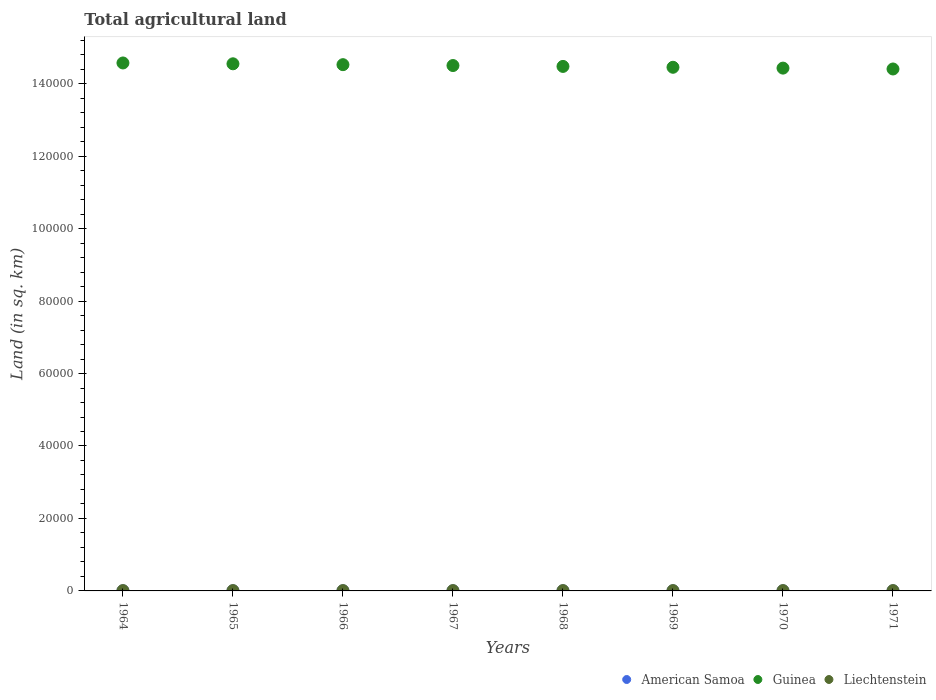How many different coloured dotlines are there?
Your response must be concise. 3. What is the total agricultural land in American Samoa in 1969?
Offer a very short reply. 30. Across all years, what is the maximum total agricultural land in Liechtenstein?
Your answer should be compact. 90. Across all years, what is the minimum total agricultural land in Liechtenstein?
Give a very brief answer. 90. In which year was the total agricultural land in American Samoa maximum?
Offer a terse response. 1964. In which year was the total agricultural land in Guinea minimum?
Your response must be concise. 1971. What is the total total agricultural land in American Samoa in the graph?
Your answer should be compact. 240. What is the difference between the total agricultural land in Guinea in 1967 and that in 1971?
Keep it short and to the point. 950. What is the difference between the total agricultural land in American Samoa in 1966 and the total agricultural land in Liechtenstein in 1971?
Keep it short and to the point. -60. In the year 1971, what is the difference between the total agricultural land in Guinea and total agricultural land in American Samoa?
Make the answer very short. 1.44e+05. In how many years, is the total agricultural land in American Samoa greater than 68000 sq.km?
Your answer should be very brief. 0. Is the difference between the total agricultural land in Guinea in 1969 and 1970 greater than the difference between the total agricultural land in American Samoa in 1969 and 1970?
Ensure brevity in your answer.  Yes. What is the difference between the highest and the lowest total agricultural land in Guinea?
Provide a succinct answer. 1660. Does the total agricultural land in American Samoa monotonically increase over the years?
Make the answer very short. No. How many years are there in the graph?
Ensure brevity in your answer.  8. What is the difference between two consecutive major ticks on the Y-axis?
Make the answer very short. 2.00e+04. Are the values on the major ticks of Y-axis written in scientific E-notation?
Offer a terse response. No. Does the graph contain any zero values?
Ensure brevity in your answer.  No. Does the graph contain grids?
Provide a short and direct response. No. How many legend labels are there?
Keep it short and to the point. 3. What is the title of the graph?
Your response must be concise. Total agricultural land. Does "New Caledonia" appear as one of the legend labels in the graph?
Offer a terse response. No. What is the label or title of the X-axis?
Provide a short and direct response. Years. What is the label or title of the Y-axis?
Make the answer very short. Land (in sq. km). What is the Land (in sq. km) in American Samoa in 1964?
Provide a succinct answer. 30. What is the Land (in sq. km) in Guinea in 1964?
Give a very brief answer. 1.46e+05. What is the Land (in sq. km) of Guinea in 1965?
Your answer should be very brief. 1.45e+05. What is the Land (in sq. km) in Liechtenstein in 1965?
Keep it short and to the point. 90. What is the Land (in sq. km) in Guinea in 1966?
Offer a terse response. 1.45e+05. What is the Land (in sq. km) of American Samoa in 1967?
Offer a very short reply. 30. What is the Land (in sq. km) of Guinea in 1967?
Your answer should be very brief. 1.45e+05. What is the Land (in sq. km) of Liechtenstein in 1967?
Keep it short and to the point. 90. What is the Land (in sq. km) in Guinea in 1968?
Your response must be concise. 1.45e+05. What is the Land (in sq. km) in Liechtenstein in 1968?
Give a very brief answer. 90. What is the Land (in sq. km) of American Samoa in 1969?
Provide a succinct answer. 30. What is the Land (in sq. km) of Guinea in 1969?
Provide a short and direct response. 1.45e+05. What is the Land (in sq. km) of Liechtenstein in 1969?
Your answer should be very brief. 90. What is the Land (in sq. km) of American Samoa in 1970?
Offer a terse response. 30. What is the Land (in sq. km) in Guinea in 1970?
Give a very brief answer. 1.44e+05. What is the Land (in sq. km) of Liechtenstein in 1970?
Give a very brief answer. 90. What is the Land (in sq. km) in Guinea in 1971?
Make the answer very short. 1.44e+05. Across all years, what is the maximum Land (in sq. km) in American Samoa?
Provide a short and direct response. 30. Across all years, what is the maximum Land (in sq. km) in Guinea?
Ensure brevity in your answer.  1.46e+05. Across all years, what is the maximum Land (in sq. km) in Liechtenstein?
Offer a terse response. 90. Across all years, what is the minimum Land (in sq. km) in American Samoa?
Make the answer very short. 30. Across all years, what is the minimum Land (in sq. km) in Guinea?
Offer a terse response. 1.44e+05. What is the total Land (in sq. km) in American Samoa in the graph?
Provide a succinct answer. 240. What is the total Land (in sq. km) of Guinea in the graph?
Offer a very short reply. 1.16e+06. What is the total Land (in sq. km) in Liechtenstein in the graph?
Ensure brevity in your answer.  720. What is the difference between the Land (in sq. km) in Guinea in 1964 and that in 1965?
Make the answer very short. 230. What is the difference between the Land (in sq. km) in Guinea in 1964 and that in 1966?
Ensure brevity in your answer.  470. What is the difference between the Land (in sq. km) of Liechtenstein in 1964 and that in 1966?
Your answer should be very brief. 0. What is the difference between the Land (in sq. km) of Guinea in 1964 and that in 1967?
Your answer should be compact. 710. What is the difference between the Land (in sq. km) of American Samoa in 1964 and that in 1968?
Offer a very short reply. 0. What is the difference between the Land (in sq. km) in Guinea in 1964 and that in 1968?
Ensure brevity in your answer.  950. What is the difference between the Land (in sq. km) of Guinea in 1964 and that in 1969?
Ensure brevity in your answer.  1190. What is the difference between the Land (in sq. km) of Guinea in 1964 and that in 1970?
Your response must be concise. 1420. What is the difference between the Land (in sq. km) in American Samoa in 1964 and that in 1971?
Keep it short and to the point. 0. What is the difference between the Land (in sq. km) of Guinea in 1964 and that in 1971?
Make the answer very short. 1660. What is the difference between the Land (in sq. km) in Liechtenstein in 1964 and that in 1971?
Make the answer very short. 0. What is the difference between the Land (in sq. km) of American Samoa in 1965 and that in 1966?
Make the answer very short. 0. What is the difference between the Land (in sq. km) of Guinea in 1965 and that in 1966?
Provide a short and direct response. 240. What is the difference between the Land (in sq. km) in American Samoa in 1965 and that in 1967?
Offer a terse response. 0. What is the difference between the Land (in sq. km) in Guinea in 1965 and that in 1967?
Provide a short and direct response. 480. What is the difference between the Land (in sq. km) in Liechtenstein in 1965 and that in 1967?
Keep it short and to the point. 0. What is the difference between the Land (in sq. km) in Guinea in 1965 and that in 1968?
Ensure brevity in your answer.  720. What is the difference between the Land (in sq. km) in Liechtenstein in 1965 and that in 1968?
Your response must be concise. 0. What is the difference between the Land (in sq. km) of Guinea in 1965 and that in 1969?
Ensure brevity in your answer.  960. What is the difference between the Land (in sq. km) in American Samoa in 1965 and that in 1970?
Keep it short and to the point. 0. What is the difference between the Land (in sq. km) in Guinea in 1965 and that in 1970?
Your answer should be very brief. 1190. What is the difference between the Land (in sq. km) in Liechtenstein in 1965 and that in 1970?
Your response must be concise. 0. What is the difference between the Land (in sq. km) in Guinea in 1965 and that in 1971?
Your answer should be compact. 1430. What is the difference between the Land (in sq. km) in Guinea in 1966 and that in 1967?
Make the answer very short. 240. What is the difference between the Land (in sq. km) in Guinea in 1966 and that in 1968?
Give a very brief answer. 480. What is the difference between the Land (in sq. km) of Liechtenstein in 1966 and that in 1968?
Your answer should be compact. 0. What is the difference between the Land (in sq. km) of American Samoa in 1966 and that in 1969?
Keep it short and to the point. 0. What is the difference between the Land (in sq. km) of Guinea in 1966 and that in 1969?
Provide a succinct answer. 720. What is the difference between the Land (in sq. km) in Liechtenstein in 1966 and that in 1969?
Make the answer very short. 0. What is the difference between the Land (in sq. km) of American Samoa in 1966 and that in 1970?
Your response must be concise. 0. What is the difference between the Land (in sq. km) in Guinea in 1966 and that in 1970?
Your response must be concise. 950. What is the difference between the Land (in sq. km) of Liechtenstein in 1966 and that in 1970?
Offer a terse response. 0. What is the difference between the Land (in sq. km) in American Samoa in 1966 and that in 1971?
Ensure brevity in your answer.  0. What is the difference between the Land (in sq. km) of Guinea in 1966 and that in 1971?
Offer a terse response. 1190. What is the difference between the Land (in sq. km) of American Samoa in 1967 and that in 1968?
Offer a very short reply. 0. What is the difference between the Land (in sq. km) of Guinea in 1967 and that in 1968?
Make the answer very short. 240. What is the difference between the Land (in sq. km) in Liechtenstein in 1967 and that in 1968?
Your response must be concise. 0. What is the difference between the Land (in sq. km) of Guinea in 1967 and that in 1969?
Make the answer very short. 480. What is the difference between the Land (in sq. km) in Liechtenstein in 1967 and that in 1969?
Your response must be concise. 0. What is the difference between the Land (in sq. km) in Guinea in 1967 and that in 1970?
Ensure brevity in your answer.  710. What is the difference between the Land (in sq. km) in Guinea in 1967 and that in 1971?
Offer a terse response. 950. What is the difference between the Land (in sq. km) of Liechtenstein in 1967 and that in 1971?
Your answer should be compact. 0. What is the difference between the Land (in sq. km) of Guinea in 1968 and that in 1969?
Offer a terse response. 240. What is the difference between the Land (in sq. km) of Liechtenstein in 1968 and that in 1969?
Give a very brief answer. 0. What is the difference between the Land (in sq. km) in Guinea in 1968 and that in 1970?
Your answer should be very brief. 470. What is the difference between the Land (in sq. km) in Liechtenstein in 1968 and that in 1970?
Your answer should be compact. 0. What is the difference between the Land (in sq. km) of American Samoa in 1968 and that in 1971?
Ensure brevity in your answer.  0. What is the difference between the Land (in sq. km) of Guinea in 1968 and that in 1971?
Ensure brevity in your answer.  710. What is the difference between the Land (in sq. km) of Liechtenstein in 1968 and that in 1971?
Give a very brief answer. 0. What is the difference between the Land (in sq. km) in American Samoa in 1969 and that in 1970?
Keep it short and to the point. 0. What is the difference between the Land (in sq. km) in Guinea in 1969 and that in 1970?
Make the answer very short. 230. What is the difference between the Land (in sq. km) of American Samoa in 1969 and that in 1971?
Ensure brevity in your answer.  0. What is the difference between the Land (in sq. km) of Guinea in 1969 and that in 1971?
Provide a short and direct response. 470. What is the difference between the Land (in sq. km) in Liechtenstein in 1969 and that in 1971?
Provide a short and direct response. 0. What is the difference between the Land (in sq. km) in American Samoa in 1970 and that in 1971?
Make the answer very short. 0. What is the difference between the Land (in sq. km) of Guinea in 1970 and that in 1971?
Provide a short and direct response. 240. What is the difference between the Land (in sq. km) of American Samoa in 1964 and the Land (in sq. km) of Guinea in 1965?
Offer a very short reply. -1.45e+05. What is the difference between the Land (in sq. km) in American Samoa in 1964 and the Land (in sq. km) in Liechtenstein in 1965?
Offer a terse response. -60. What is the difference between the Land (in sq. km) in Guinea in 1964 and the Land (in sq. km) in Liechtenstein in 1965?
Offer a terse response. 1.46e+05. What is the difference between the Land (in sq. km) in American Samoa in 1964 and the Land (in sq. km) in Guinea in 1966?
Your answer should be very brief. -1.45e+05. What is the difference between the Land (in sq. km) in American Samoa in 1964 and the Land (in sq. km) in Liechtenstein in 1966?
Provide a short and direct response. -60. What is the difference between the Land (in sq. km) in Guinea in 1964 and the Land (in sq. km) in Liechtenstein in 1966?
Your response must be concise. 1.46e+05. What is the difference between the Land (in sq. km) of American Samoa in 1964 and the Land (in sq. km) of Guinea in 1967?
Your response must be concise. -1.45e+05. What is the difference between the Land (in sq. km) of American Samoa in 1964 and the Land (in sq. km) of Liechtenstein in 1967?
Your answer should be compact. -60. What is the difference between the Land (in sq. km) of Guinea in 1964 and the Land (in sq. km) of Liechtenstein in 1967?
Ensure brevity in your answer.  1.46e+05. What is the difference between the Land (in sq. km) in American Samoa in 1964 and the Land (in sq. km) in Guinea in 1968?
Your answer should be very brief. -1.45e+05. What is the difference between the Land (in sq. km) in American Samoa in 1964 and the Land (in sq. km) in Liechtenstein in 1968?
Your response must be concise. -60. What is the difference between the Land (in sq. km) of Guinea in 1964 and the Land (in sq. km) of Liechtenstein in 1968?
Your answer should be compact. 1.46e+05. What is the difference between the Land (in sq. km) of American Samoa in 1964 and the Land (in sq. km) of Guinea in 1969?
Ensure brevity in your answer.  -1.44e+05. What is the difference between the Land (in sq. km) in American Samoa in 1964 and the Land (in sq. km) in Liechtenstein in 1969?
Keep it short and to the point. -60. What is the difference between the Land (in sq. km) of Guinea in 1964 and the Land (in sq. km) of Liechtenstein in 1969?
Provide a succinct answer. 1.46e+05. What is the difference between the Land (in sq. km) of American Samoa in 1964 and the Land (in sq. km) of Guinea in 1970?
Give a very brief answer. -1.44e+05. What is the difference between the Land (in sq. km) of American Samoa in 1964 and the Land (in sq. km) of Liechtenstein in 1970?
Provide a succinct answer. -60. What is the difference between the Land (in sq. km) of Guinea in 1964 and the Land (in sq. km) of Liechtenstein in 1970?
Give a very brief answer. 1.46e+05. What is the difference between the Land (in sq. km) of American Samoa in 1964 and the Land (in sq. km) of Guinea in 1971?
Ensure brevity in your answer.  -1.44e+05. What is the difference between the Land (in sq. km) of American Samoa in 1964 and the Land (in sq. km) of Liechtenstein in 1971?
Keep it short and to the point. -60. What is the difference between the Land (in sq. km) in Guinea in 1964 and the Land (in sq. km) in Liechtenstein in 1971?
Make the answer very short. 1.46e+05. What is the difference between the Land (in sq. km) in American Samoa in 1965 and the Land (in sq. km) in Guinea in 1966?
Keep it short and to the point. -1.45e+05. What is the difference between the Land (in sq. km) of American Samoa in 1965 and the Land (in sq. km) of Liechtenstein in 1966?
Your answer should be compact. -60. What is the difference between the Land (in sq. km) in Guinea in 1965 and the Land (in sq. km) in Liechtenstein in 1966?
Your response must be concise. 1.45e+05. What is the difference between the Land (in sq. km) in American Samoa in 1965 and the Land (in sq. km) in Guinea in 1967?
Keep it short and to the point. -1.45e+05. What is the difference between the Land (in sq. km) in American Samoa in 1965 and the Land (in sq. km) in Liechtenstein in 1967?
Make the answer very short. -60. What is the difference between the Land (in sq. km) of Guinea in 1965 and the Land (in sq. km) of Liechtenstein in 1967?
Your response must be concise. 1.45e+05. What is the difference between the Land (in sq. km) of American Samoa in 1965 and the Land (in sq. km) of Guinea in 1968?
Ensure brevity in your answer.  -1.45e+05. What is the difference between the Land (in sq. km) in American Samoa in 1965 and the Land (in sq. km) in Liechtenstein in 1968?
Your answer should be very brief. -60. What is the difference between the Land (in sq. km) of Guinea in 1965 and the Land (in sq. km) of Liechtenstein in 1968?
Keep it short and to the point. 1.45e+05. What is the difference between the Land (in sq. km) of American Samoa in 1965 and the Land (in sq. km) of Guinea in 1969?
Your response must be concise. -1.44e+05. What is the difference between the Land (in sq. km) of American Samoa in 1965 and the Land (in sq. km) of Liechtenstein in 1969?
Your answer should be compact. -60. What is the difference between the Land (in sq. km) in Guinea in 1965 and the Land (in sq. km) in Liechtenstein in 1969?
Provide a short and direct response. 1.45e+05. What is the difference between the Land (in sq. km) of American Samoa in 1965 and the Land (in sq. km) of Guinea in 1970?
Your answer should be very brief. -1.44e+05. What is the difference between the Land (in sq. km) in American Samoa in 1965 and the Land (in sq. km) in Liechtenstein in 1970?
Your response must be concise. -60. What is the difference between the Land (in sq. km) in Guinea in 1965 and the Land (in sq. km) in Liechtenstein in 1970?
Provide a short and direct response. 1.45e+05. What is the difference between the Land (in sq. km) in American Samoa in 1965 and the Land (in sq. km) in Guinea in 1971?
Your answer should be compact. -1.44e+05. What is the difference between the Land (in sq. km) in American Samoa in 1965 and the Land (in sq. km) in Liechtenstein in 1971?
Your response must be concise. -60. What is the difference between the Land (in sq. km) of Guinea in 1965 and the Land (in sq. km) of Liechtenstein in 1971?
Keep it short and to the point. 1.45e+05. What is the difference between the Land (in sq. km) of American Samoa in 1966 and the Land (in sq. km) of Guinea in 1967?
Make the answer very short. -1.45e+05. What is the difference between the Land (in sq. km) of American Samoa in 1966 and the Land (in sq. km) of Liechtenstein in 1967?
Offer a very short reply. -60. What is the difference between the Land (in sq. km) in Guinea in 1966 and the Land (in sq. km) in Liechtenstein in 1967?
Give a very brief answer. 1.45e+05. What is the difference between the Land (in sq. km) in American Samoa in 1966 and the Land (in sq. km) in Guinea in 1968?
Provide a succinct answer. -1.45e+05. What is the difference between the Land (in sq. km) in American Samoa in 1966 and the Land (in sq. km) in Liechtenstein in 1968?
Give a very brief answer. -60. What is the difference between the Land (in sq. km) in Guinea in 1966 and the Land (in sq. km) in Liechtenstein in 1968?
Make the answer very short. 1.45e+05. What is the difference between the Land (in sq. km) of American Samoa in 1966 and the Land (in sq. km) of Guinea in 1969?
Offer a terse response. -1.44e+05. What is the difference between the Land (in sq. km) of American Samoa in 1966 and the Land (in sq. km) of Liechtenstein in 1969?
Offer a very short reply. -60. What is the difference between the Land (in sq. km) in Guinea in 1966 and the Land (in sq. km) in Liechtenstein in 1969?
Give a very brief answer. 1.45e+05. What is the difference between the Land (in sq. km) of American Samoa in 1966 and the Land (in sq. km) of Guinea in 1970?
Make the answer very short. -1.44e+05. What is the difference between the Land (in sq. km) of American Samoa in 1966 and the Land (in sq. km) of Liechtenstein in 1970?
Offer a terse response. -60. What is the difference between the Land (in sq. km) of Guinea in 1966 and the Land (in sq. km) of Liechtenstein in 1970?
Keep it short and to the point. 1.45e+05. What is the difference between the Land (in sq. km) in American Samoa in 1966 and the Land (in sq. km) in Guinea in 1971?
Keep it short and to the point. -1.44e+05. What is the difference between the Land (in sq. km) in American Samoa in 1966 and the Land (in sq. km) in Liechtenstein in 1971?
Ensure brevity in your answer.  -60. What is the difference between the Land (in sq. km) of Guinea in 1966 and the Land (in sq. km) of Liechtenstein in 1971?
Your answer should be compact. 1.45e+05. What is the difference between the Land (in sq. km) of American Samoa in 1967 and the Land (in sq. km) of Guinea in 1968?
Your response must be concise. -1.45e+05. What is the difference between the Land (in sq. km) in American Samoa in 1967 and the Land (in sq. km) in Liechtenstein in 1968?
Your answer should be very brief. -60. What is the difference between the Land (in sq. km) in Guinea in 1967 and the Land (in sq. km) in Liechtenstein in 1968?
Offer a terse response. 1.45e+05. What is the difference between the Land (in sq. km) in American Samoa in 1967 and the Land (in sq. km) in Guinea in 1969?
Your answer should be compact. -1.44e+05. What is the difference between the Land (in sq. km) of American Samoa in 1967 and the Land (in sq. km) of Liechtenstein in 1969?
Make the answer very short. -60. What is the difference between the Land (in sq. km) of Guinea in 1967 and the Land (in sq. km) of Liechtenstein in 1969?
Make the answer very short. 1.45e+05. What is the difference between the Land (in sq. km) in American Samoa in 1967 and the Land (in sq. km) in Guinea in 1970?
Keep it short and to the point. -1.44e+05. What is the difference between the Land (in sq. km) of American Samoa in 1967 and the Land (in sq. km) of Liechtenstein in 1970?
Offer a terse response. -60. What is the difference between the Land (in sq. km) in Guinea in 1967 and the Land (in sq. km) in Liechtenstein in 1970?
Make the answer very short. 1.45e+05. What is the difference between the Land (in sq. km) in American Samoa in 1967 and the Land (in sq. km) in Guinea in 1971?
Make the answer very short. -1.44e+05. What is the difference between the Land (in sq. km) in American Samoa in 1967 and the Land (in sq. km) in Liechtenstein in 1971?
Your response must be concise. -60. What is the difference between the Land (in sq. km) of Guinea in 1967 and the Land (in sq. km) of Liechtenstein in 1971?
Give a very brief answer. 1.45e+05. What is the difference between the Land (in sq. km) of American Samoa in 1968 and the Land (in sq. km) of Guinea in 1969?
Your response must be concise. -1.44e+05. What is the difference between the Land (in sq. km) in American Samoa in 1968 and the Land (in sq. km) in Liechtenstein in 1969?
Ensure brevity in your answer.  -60. What is the difference between the Land (in sq. km) in Guinea in 1968 and the Land (in sq. km) in Liechtenstein in 1969?
Give a very brief answer. 1.45e+05. What is the difference between the Land (in sq. km) in American Samoa in 1968 and the Land (in sq. km) in Guinea in 1970?
Make the answer very short. -1.44e+05. What is the difference between the Land (in sq. km) in American Samoa in 1968 and the Land (in sq. km) in Liechtenstein in 1970?
Offer a very short reply. -60. What is the difference between the Land (in sq. km) of Guinea in 1968 and the Land (in sq. km) of Liechtenstein in 1970?
Provide a short and direct response. 1.45e+05. What is the difference between the Land (in sq. km) in American Samoa in 1968 and the Land (in sq. km) in Guinea in 1971?
Your response must be concise. -1.44e+05. What is the difference between the Land (in sq. km) of American Samoa in 1968 and the Land (in sq. km) of Liechtenstein in 1971?
Provide a short and direct response. -60. What is the difference between the Land (in sq. km) in Guinea in 1968 and the Land (in sq. km) in Liechtenstein in 1971?
Your answer should be compact. 1.45e+05. What is the difference between the Land (in sq. km) of American Samoa in 1969 and the Land (in sq. km) of Guinea in 1970?
Make the answer very short. -1.44e+05. What is the difference between the Land (in sq. km) of American Samoa in 1969 and the Land (in sq. km) of Liechtenstein in 1970?
Ensure brevity in your answer.  -60. What is the difference between the Land (in sq. km) in Guinea in 1969 and the Land (in sq. km) in Liechtenstein in 1970?
Give a very brief answer. 1.44e+05. What is the difference between the Land (in sq. km) in American Samoa in 1969 and the Land (in sq. km) in Guinea in 1971?
Your answer should be very brief. -1.44e+05. What is the difference between the Land (in sq. km) in American Samoa in 1969 and the Land (in sq. km) in Liechtenstein in 1971?
Provide a succinct answer. -60. What is the difference between the Land (in sq. km) in Guinea in 1969 and the Land (in sq. km) in Liechtenstein in 1971?
Your answer should be very brief. 1.44e+05. What is the difference between the Land (in sq. km) in American Samoa in 1970 and the Land (in sq. km) in Guinea in 1971?
Provide a succinct answer. -1.44e+05. What is the difference between the Land (in sq. km) in American Samoa in 1970 and the Land (in sq. km) in Liechtenstein in 1971?
Keep it short and to the point. -60. What is the difference between the Land (in sq. km) in Guinea in 1970 and the Land (in sq. km) in Liechtenstein in 1971?
Offer a very short reply. 1.44e+05. What is the average Land (in sq. km) in Guinea per year?
Give a very brief answer. 1.45e+05. What is the average Land (in sq. km) in Liechtenstein per year?
Ensure brevity in your answer.  90. In the year 1964, what is the difference between the Land (in sq. km) of American Samoa and Land (in sq. km) of Guinea?
Offer a terse response. -1.46e+05. In the year 1964, what is the difference between the Land (in sq. km) in American Samoa and Land (in sq. km) in Liechtenstein?
Provide a succinct answer. -60. In the year 1964, what is the difference between the Land (in sq. km) in Guinea and Land (in sq. km) in Liechtenstein?
Your response must be concise. 1.46e+05. In the year 1965, what is the difference between the Land (in sq. km) of American Samoa and Land (in sq. km) of Guinea?
Your answer should be compact. -1.45e+05. In the year 1965, what is the difference between the Land (in sq. km) in American Samoa and Land (in sq. km) in Liechtenstein?
Your answer should be compact. -60. In the year 1965, what is the difference between the Land (in sq. km) of Guinea and Land (in sq. km) of Liechtenstein?
Your response must be concise. 1.45e+05. In the year 1966, what is the difference between the Land (in sq. km) of American Samoa and Land (in sq. km) of Guinea?
Provide a succinct answer. -1.45e+05. In the year 1966, what is the difference between the Land (in sq. km) of American Samoa and Land (in sq. km) of Liechtenstein?
Offer a terse response. -60. In the year 1966, what is the difference between the Land (in sq. km) of Guinea and Land (in sq. km) of Liechtenstein?
Your answer should be compact. 1.45e+05. In the year 1967, what is the difference between the Land (in sq. km) of American Samoa and Land (in sq. km) of Guinea?
Provide a succinct answer. -1.45e+05. In the year 1967, what is the difference between the Land (in sq. km) of American Samoa and Land (in sq. km) of Liechtenstein?
Make the answer very short. -60. In the year 1967, what is the difference between the Land (in sq. km) in Guinea and Land (in sq. km) in Liechtenstein?
Your answer should be compact. 1.45e+05. In the year 1968, what is the difference between the Land (in sq. km) in American Samoa and Land (in sq. km) in Guinea?
Offer a terse response. -1.45e+05. In the year 1968, what is the difference between the Land (in sq. km) in American Samoa and Land (in sq. km) in Liechtenstein?
Keep it short and to the point. -60. In the year 1968, what is the difference between the Land (in sq. km) of Guinea and Land (in sq. km) of Liechtenstein?
Offer a very short reply. 1.45e+05. In the year 1969, what is the difference between the Land (in sq. km) of American Samoa and Land (in sq. km) of Guinea?
Your response must be concise. -1.44e+05. In the year 1969, what is the difference between the Land (in sq. km) of American Samoa and Land (in sq. km) of Liechtenstein?
Offer a very short reply. -60. In the year 1969, what is the difference between the Land (in sq. km) in Guinea and Land (in sq. km) in Liechtenstein?
Keep it short and to the point. 1.44e+05. In the year 1970, what is the difference between the Land (in sq. km) in American Samoa and Land (in sq. km) in Guinea?
Make the answer very short. -1.44e+05. In the year 1970, what is the difference between the Land (in sq. km) in American Samoa and Land (in sq. km) in Liechtenstein?
Make the answer very short. -60. In the year 1970, what is the difference between the Land (in sq. km) in Guinea and Land (in sq. km) in Liechtenstein?
Offer a very short reply. 1.44e+05. In the year 1971, what is the difference between the Land (in sq. km) of American Samoa and Land (in sq. km) of Guinea?
Ensure brevity in your answer.  -1.44e+05. In the year 1971, what is the difference between the Land (in sq. km) of American Samoa and Land (in sq. km) of Liechtenstein?
Offer a very short reply. -60. In the year 1971, what is the difference between the Land (in sq. km) in Guinea and Land (in sq. km) in Liechtenstein?
Your answer should be compact. 1.44e+05. What is the ratio of the Land (in sq. km) in American Samoa in 1964 to that in 1965?
Your response must be concise. 1. What is the ratio of the Land (in sq. km) of Guinea in 1964 to that in 1965?
Ensure brevity in your answer.  1. What is the ratio of the Land (in sq. km) in Liechtenstein in 1964 to that in 1965?
Offer a terse response. 1. What is the ratio of the Land (in sq. km) in American Samoa in 1964 to that in 1966?
Ensure brevity in your answer.  1. What is the ratio of the Land (in sq. km) of Liechtenstein in 1964 to that in 1966?
Offer a very short reply. 1. What is the ratio of the Land (in sq. km) of American Samoa in 1964 to that in 1967?
Give a very brief answer. 1. What is the ratio of the Land (in sq. km) of Guinea in 1964 to that in 1967?
Your answer should be compact. 1. What is the ratio of the Land (in sq. km) of Liechtenstein in 1964 to that in 1967?
Offer a very short reply. 1. What is the ratio of the Land (in sq. km) of Guinea in 1964 to that in 1968?
Keep it short and to the point. 1.01. What is the ratio of the Land (in sq. km) of Guinea in 1964 to that in 1969?
Provide a short and direct response. 1.01. What is the ratio of the Land (in sq. km) of Liechtenstein in 1964 to that in 1969?
Give a very brief answer. 1. What is the ratio of the Land (in sq. km) in American Samoa in 1964 to that in 1970?
Your answer should be very brief. 1. What is the ratio of the Land (in sq. km) in Guinea in 1964 to that in 1970?
Provide a short and direct response. 1.01. What is the ratio of the Land (in sq. km) in American Samoa in 1964 to that in 1971?
Your answer should be compact. 1. What is the ratio of the Land (in sq. km) of Guinea in 1964 to that in 1971?
Your response must be concise. 1.01. What is the ratio of the Land (in sq. km) of Liechtenstein in 1964 to that in 1971?
Offer a terse response. 1. What is the ratio of the Land (in sq. km) in American Samoa in 1965 to that in 1966?
Provide a short and direct response. 1. What is the ratio of the Land (in sq. km) of American Samoa in 1965 to that in 1967?
Ensure brevity in your answer.  1. What is the ratio of the Land (in sq. km) of American Samoa in 1965 to that in 1968?
Your answer should be compact. 1. What is the ratio of the Land (in sq. km) of American Samoa in 1965 to that in 1969?
Offer a very short reply. 1. What is the ratio of the Land (in sq. km) in Guinea in 1965 to that in 1969?
Your answer should be very brief. 1.01. What is the ratio of the Land (in sq. km) in Liechtenstein in 1965 to that in 1969?
Keep it short and to the point. 1. What is the ratio of the Land (in sq. km) in American Samoa in 1965 to that in 1970?
Ensure brevity in your answer.  1. What is the ratio of the Land (in sq. km) in Guinea in 1965 to that in 1970?
Give a very brief answer. 1.01. What is the ratio of the Land (in sq. km) of Guinea in 1965 to that in 1971?
Your answer should be very brief. 1.01. What is the ratio of the Land (in sq. km) of Liechtenstein in 1965 to that in 1971?
Your answer should be compact. 1. What is the ratio of the Land (in sq. km) in American Samoa in 1966 to that in 1967?
Give a very brief answer. 1. What is the ratio of the Land (in sq. km) of Guinea in 1966 to that in 1967?
Your answer should be very brief. 1. What is the ratio of the Land (in sq. km) of Liechtenstein in 1966 to that in 1967?
Offer a terse response. 1. What is the ratio of the Land (in sq. km) in Guinea in 1966 to that in 1968?
Your answer should be very brief. 1. What is the ratio of the Land (in sq. km) in Liechtenstein in 1966 to that in 1968?
Your answer should be compact. 1. What is the ratio of the Land (in sq. km) of Guinea in 1966 to that in 1969?
Offer a very short reply. 1. What is the ratio of the Land (in sq. km) of Liechtenstein in 1966 to that in 1969?
Provide a short and direct response. 1. What is the ratio of the Land (in sq. km) in American Samoa in 1966 to that in 1970?
Offer a terse response. 1. What is the ratio of the Land (in sq. km) in Guinea in 1966 to that in 1970?
Offer a very short reply. 1.01. What is the ratio of the Land (in sq. km) of Liechtenstein in 1966 to that in 1970?
Ensure brevity in your answer.  1. What is the ratio of the Land (in sq. km) of American Samoa in 1966 to that in 1971?
Your answer should be very brief. 1. What is the ratio of the Land (in sq. km) in Guinea in 1966 to that in 1971?
Provide a succinct answer. 1.01. What is the ratio of the Land (in sq. km) in Liechtenstein in 1966 to that in 1971?
Offer a very short reply. 1. What is the ratio of the Land (in sq. km) of Guinea in 1967 to that in 1968?
Your response must be concise. 1. What is the ratio of the Land (in sq. km) of American Samoa in 1967 to that in 1969?
Your answer should be very brief. 1. What is the ratio of the Land (in sq. km) in Liechtenstein in 1967 to that in 1970?
Ensure brevity in your answer.  1. What is the ratio of the Land (in sq. km) of American Samoa in 1967 to that in 1971?
Offer a very short reply. 1. What is the ratio of the Land (in sq. km) of Guinea in 1967 to that in 1971?
Your answer should be compact. 1.01. What is the ratio of the Land (in sq. km) in Liechtenstein in 1968 to that in 1969?
Give a very brief answer. 1. What is the ratio of the Land (in sq. km) in Guinea in 1968 to that in 1970?
Make the answer very short. 1. What is the ratio of the Land (in sq. km) of Liechtenstein in 1968 to that in 1970?
Offer a very short reply. 1. What is the ratio of the Land (in sq. km) of American Samoa in 1968 to that in 1971?
Give a very brief answer. 1. What is the ratio of the Land (in sq. km) in Guinea in 1968 to that in 1971?
Offer a very short reply. 1. What is the ratio of the Land (in sq. km) of Liechtenstein in 1968 to that in 1971?
Your answer should be compact. 1. What is the ratio of the Land (in sq. km) in Liechtenstein in 1969 to that in 1971?
Your response must be concise. 1. What is the difference between the highest and the second highest Land (in sq. km) of American Samoa?
Provide a short and direct response. 0. What is the difference between the highest and the second highest Land (in sq. km) of Guinea?
Provide a short and direct response. 230. What is the difference between the highest and the second highest Land (in sq. km) in Liechtenstein?
Your response must be concise. 0. What is the difference between the highest and the lowest Land (in sq. km) of American Samoa?
Make the answer very short. 0. What is the difference between the highest and the lowest Land (in sq. km) of Guinea?
Your answer should be compact. 1660. 